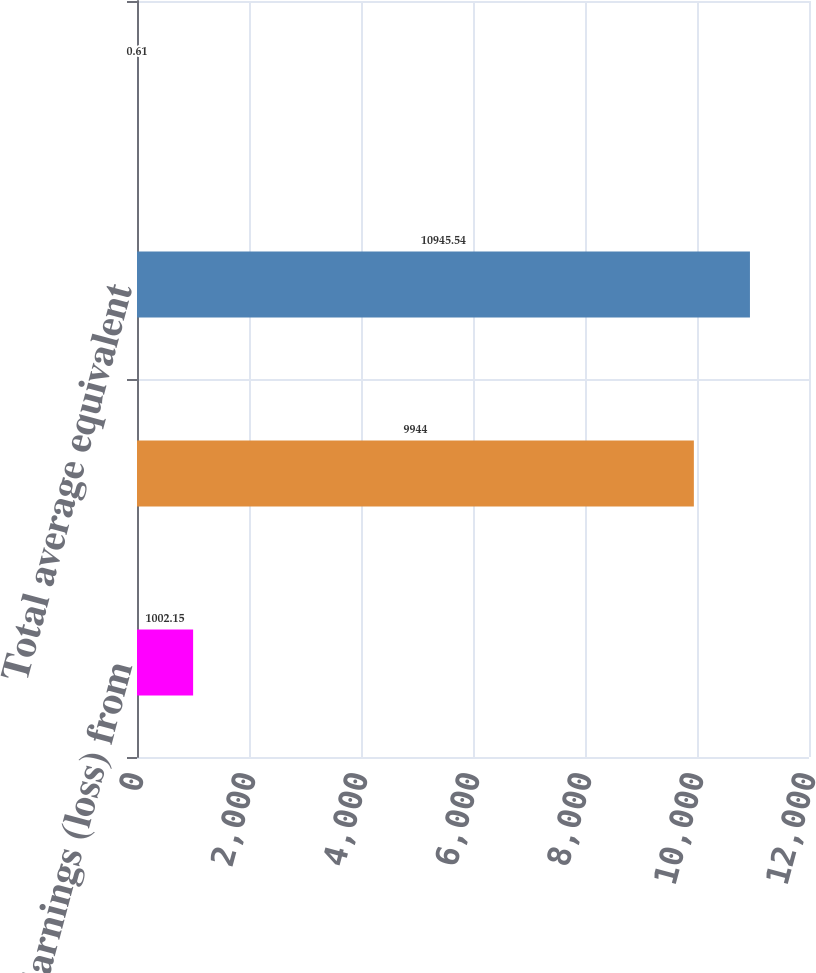<chart> <loc_0><loc_0><loc_500><loc_500><bar_chart><fcel>Earnings (loss) from<fcel>Shares of GE common stock<fcel>Total average equivalent<fcel>Net earnings (loss)<nl><fcel>1002.15<fcel>9944<fcel>10945.5<fcel>0.61<nl></chart> 